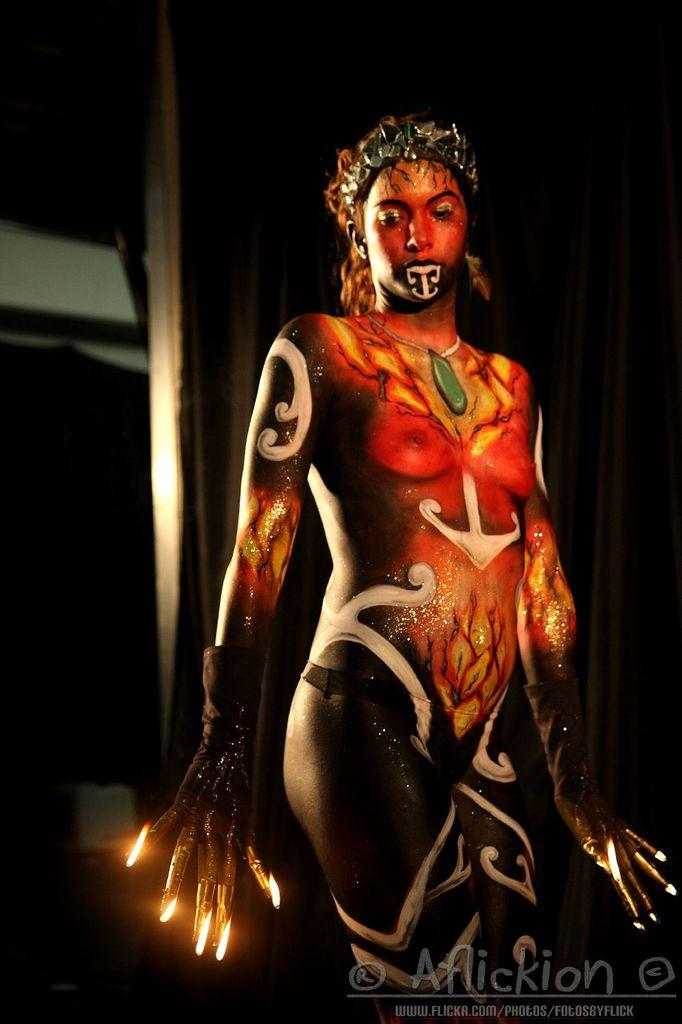Who is the main subject in the image? There is a lady in the image. What is unique about the lady's appearance? The lady has different types of painting on her. Can you describe any text visible in the image? There is a text in the foreground of the image. Can you describe the kiss between the two individuals in the image? There are no individuals kissing in the image; it features a lady with different types of painting on her and text in the foreground. 